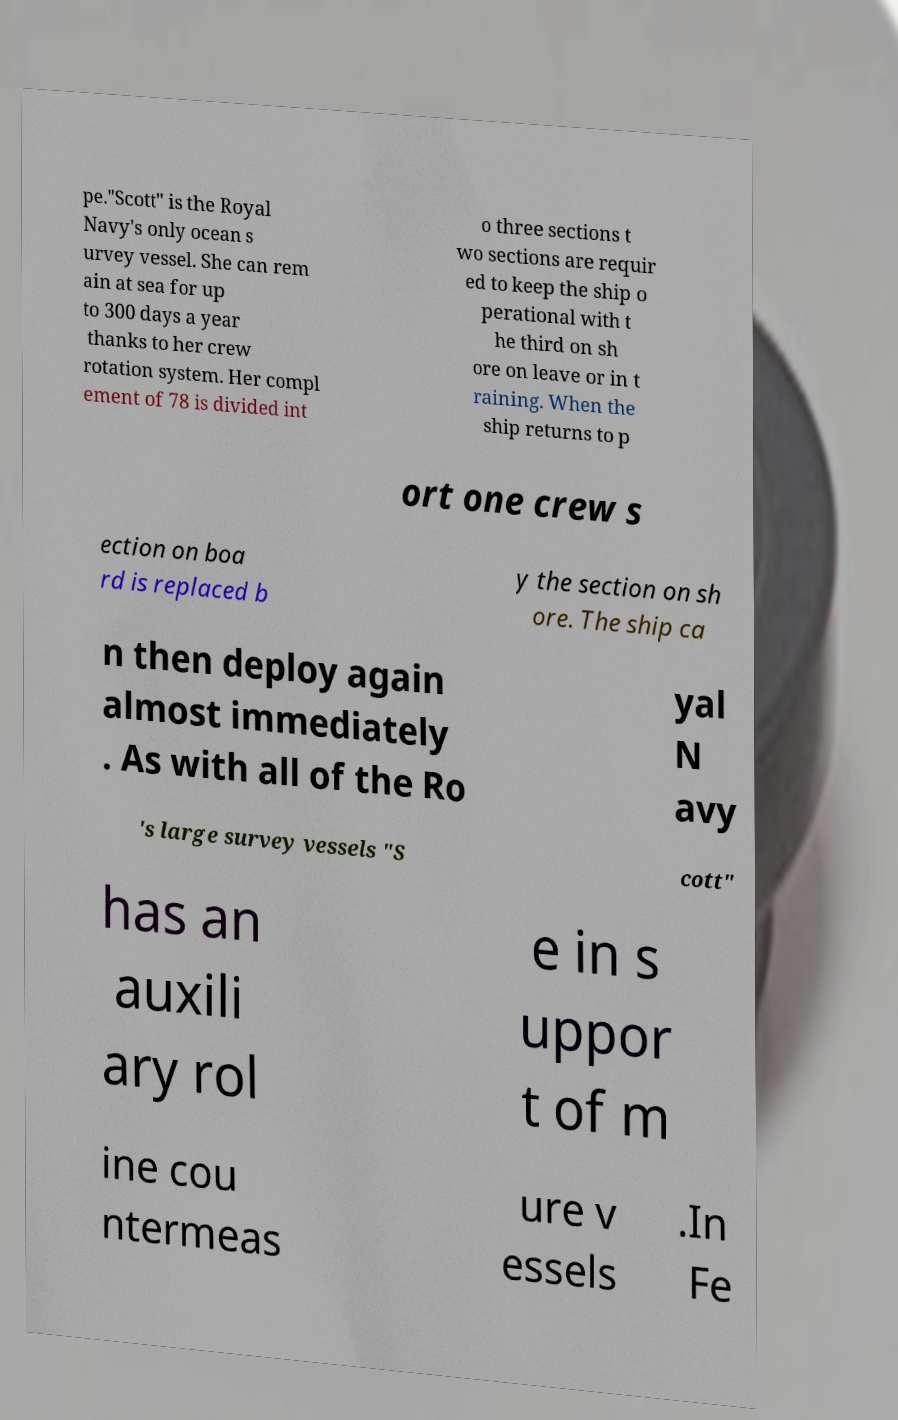Please read and relay the text visible in this image. What does it say? pe."Scott" is the Royal Navy's only ocean s urvey vessel. She can rem ain at sea for up to 300 days a year thanks to her crew rotation system. Her compl ement of 78 is divided int o three sections t wo sections are requir ed to keep the ship o perational with t he third on sh ore on leave or in t raining. When the ship returns to p ort one crew s ection on boa rd is replaced b y the section on sh ore. The ship ca n then deploy again almost immediately . As with all of the Ro yal N avy 's large survey vessels "S cott" has an auxili ary rol e in s uppor t of m ine cou ntermeas ure v essels .In Fe 